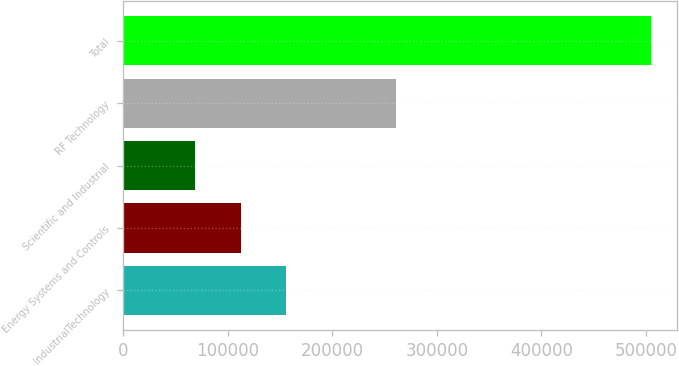<chart> <loc_0><loc_0><loc_500><loc_500><bar_chart><fcel>IndustrialTechnology<fcel>Energy Systems and Controls<fcel>Scientific and Industrial<fcel>RF Technology<fcel>Total<nl><fcel>155800<fcel>112200<fcel>68600<fcel>261243<fcel>504599<nl></chart> 